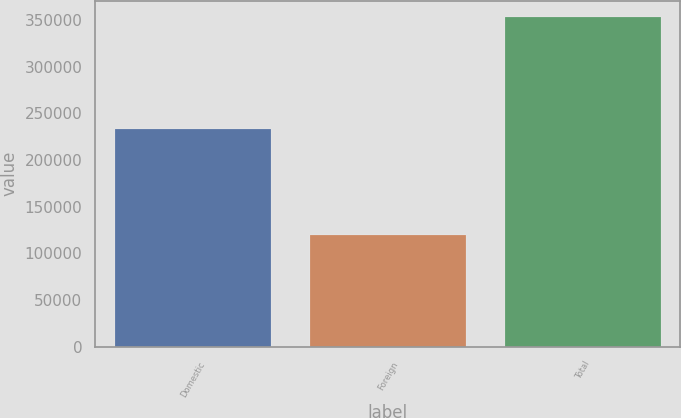Convert chart. <chart><loc_0><loc_0><loc_500><loc_500><bar_chart><fcel>Domestic<fcel>Foreign<fcel>Total<nl><fcel>233530<fcel>119599<fcel>353129<nl></chart> 